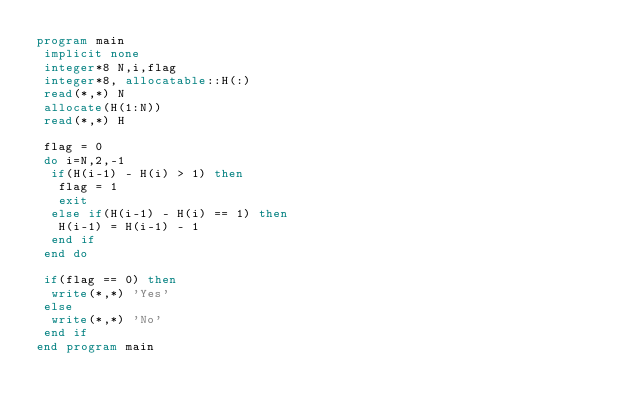Convert code to text. <code><loc_0><loc_0><loc_500><loc_500><_FORTRAN_>program main
 implicit none
 integer*8 N,i,flag
 integer*8, allocatable::H(:)
 read(*,*) N
 allocate(H(1:N))
 read(*,*) H
 
 flag = 0
 do i=N,2,-1
  if(H(i-1) - H(i) > 1) then
   flag = 1
   exit
  else if(H(i-1) - H(i) == 1) then
   H(i-1) = H(i-1) - 1
  end if
 end do
 
 if(flag == 0) then
  write(*,*) 'Yes'
 else 
  write(*,*) 'No'
 end if
end program main</code> 